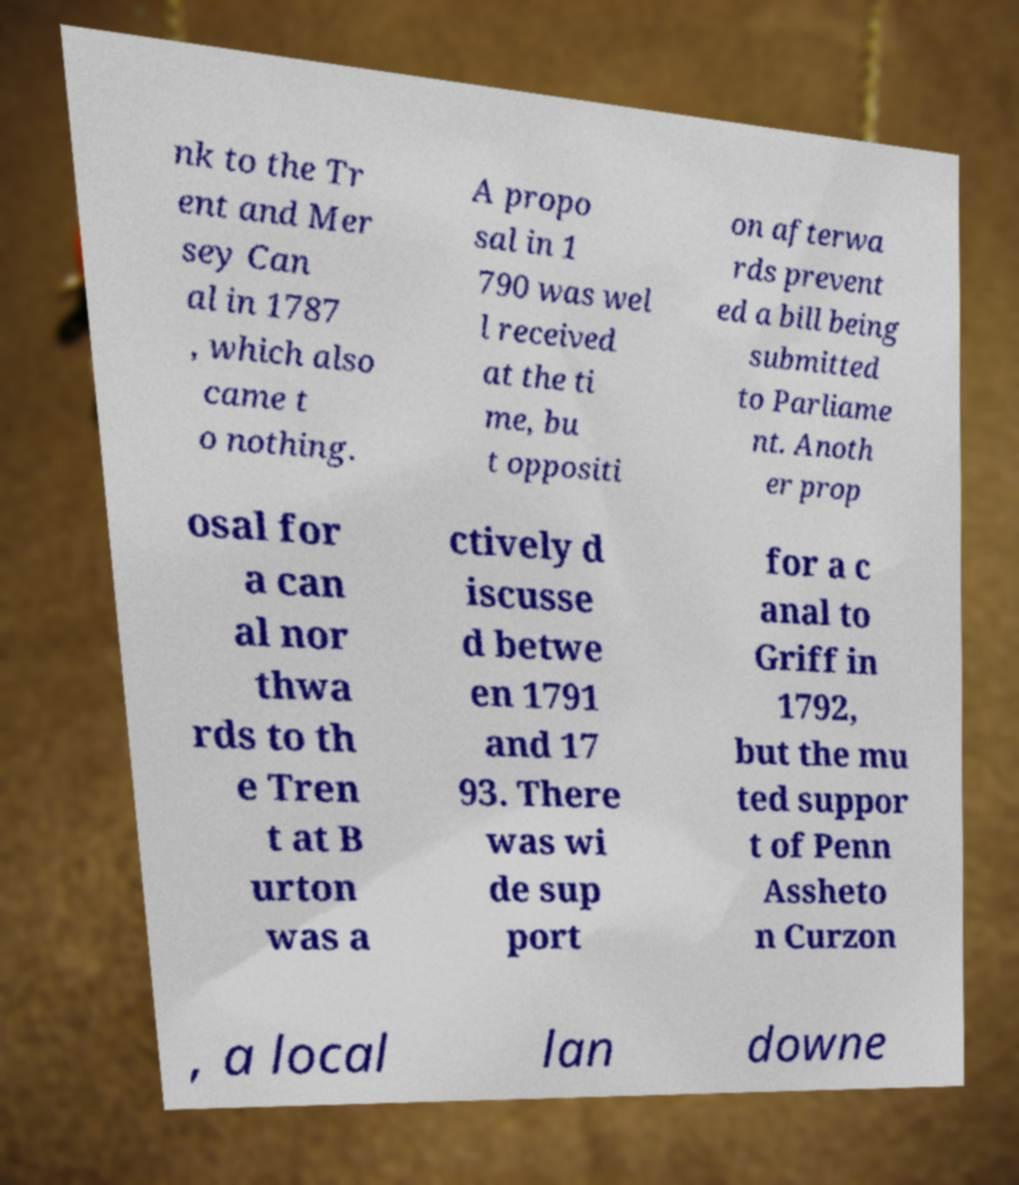Could you assist in decoding the text presented in this image and type it out clearly? nk to the Tr ent and Mer sey Can al in 1787 , which also came t o nothing. A propo sal in 1 790 was wel l received at the ti me, bu t oppositi on afterwa rds prevent ed a bill being submitted to Parliame nt. Anoth er prop osal for a can al nor thwa rds to th e Tren t at B urton was a ctively d iscusse d betwe en 1791 and 17 93. There was wi de sup port for a c anal to Griff in 1792, but the mu ted suppor t of Penn Assheto n Curzon , a local lan downe 